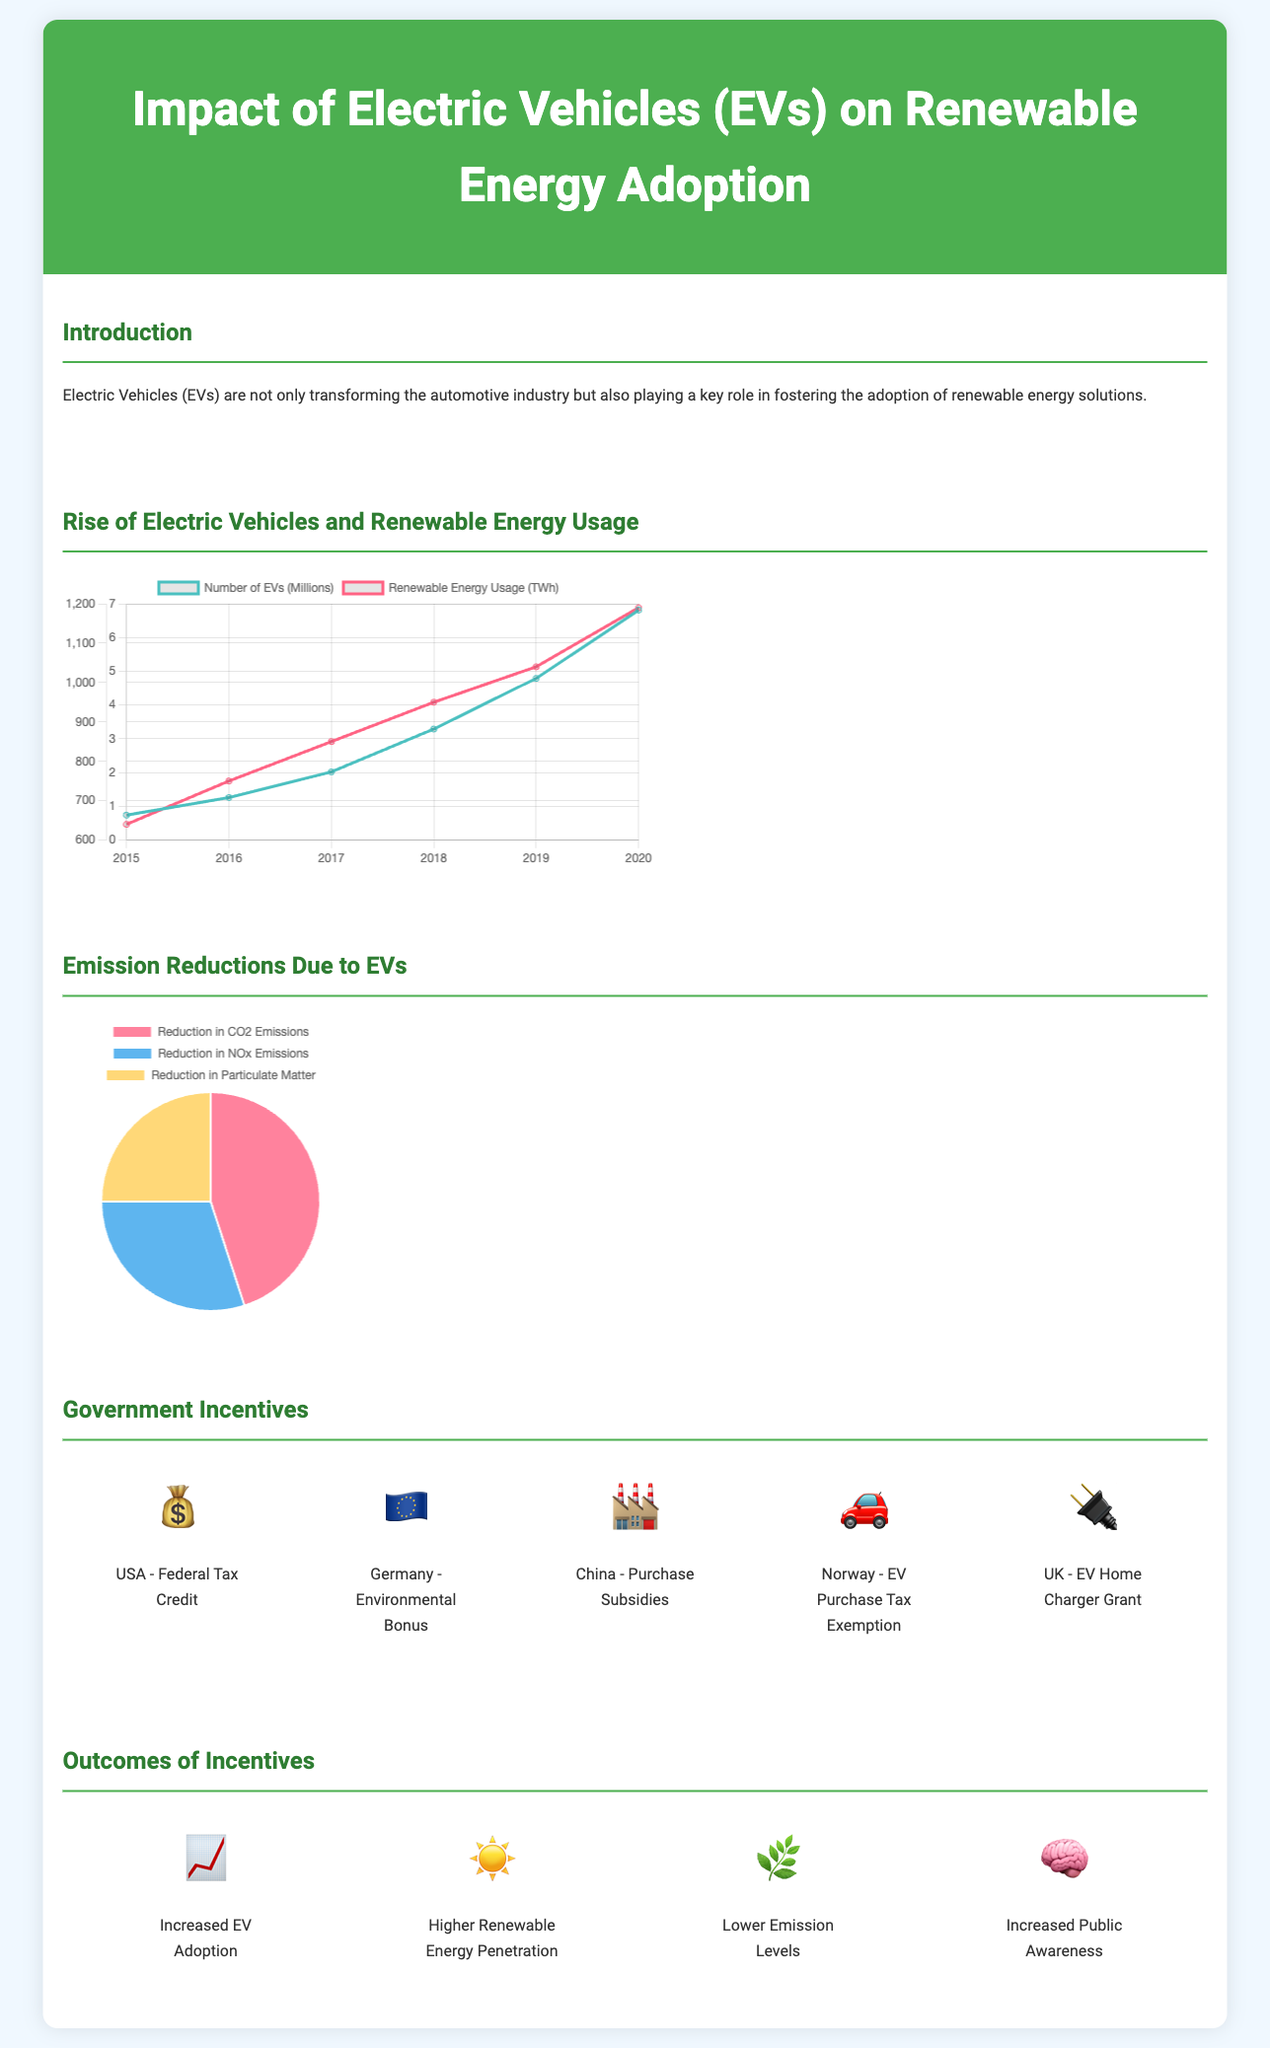What year shows the highest number of EVs? In the dual-axis chart, the year with the highest number of EVs is 2020, which shows 6.81 million EVs.
Answer: 2020 What is the amount of renewable energy usage in 2018? The dual-axis chart indicates that renewable energy usage in 2018 was 950 TWh.
Answer: 950 TWh What percentage of emission reductions is attributed to CO2 emissions? The pie chart shows that 45% of emissions reductions is due to CO2 emissions.
Answer: 45% Which country offers a Federal Tax Credit as an incentive? The infographic lists the USA as having a Federal Tax Credit as an incentive for EV adoption.
Answer: USA What is one visible outcome of government incentives mentioned in the infographic? The infographic states that one outcome of government incentives is "Increased EV Adoption."
Answer: Increased EV Adoption What type of chart illustrates emissions reductions? The emissions reductions are depicted using a pie chart in the document.
Answer: Pie chart What was the number of EVs in 2016? According to the dual-axis chart, the number of EVs in 2016 was 1.26 million.
Answer: 1.26 million What is the title of the infographic? The title of the infographic is "Impact of Electric Vehicles (EVs) on Renewable Energy Adoption."
Answer: Impact of Electric Vehicles (EVs) on Renewable Energy Adoption 